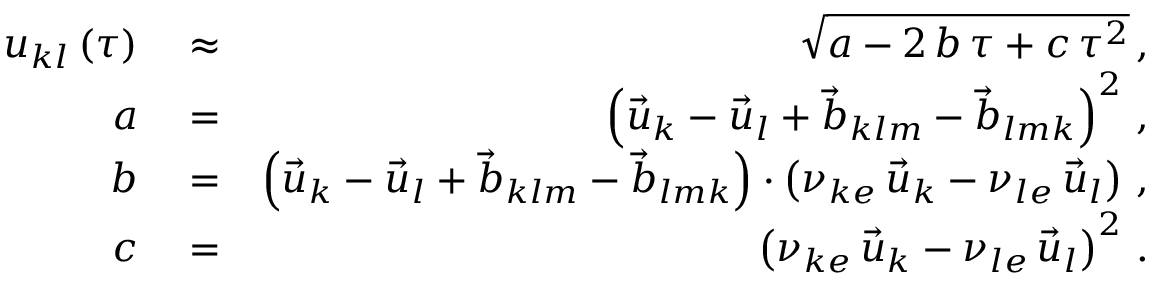<formula> <loc_0><loc_0><loc_500><loc_500>\begin{array} { r l r } { u _ { k l } \left ( \tau \right ) } & \approx } & { \sqrt { a - 2 \, b \, \tau + c \, \tau ^ { 2 } } \, , } \\ { a } & = } & { \left ( \vec { u } _ { k } - \vec { u } _ { l } + \vec { b } _ { k l m } - \vec { b } _ { l m k } \right ) ^ { 2 } \, , } \\ { b } & = } & { \left ( \vec { u } _ { k } - \vec { u } _ { l } + \vec { b } _ { k l m } - \vec { b } _ { l m k } \right ) \cdot \left ( \nu _ { k e } \, \vec { u } _ { k } - \nu _ { l e } \, \vec { u } _ { l } \right ) \, , } \\ { c } & = } & { \left ( \nu _ { k e } \, \vec { u } _ { k } - \nu _ { l e } \, \vec { u } _ { l } \right ) ^ { 2 } \, . } \end{array}</formula> 